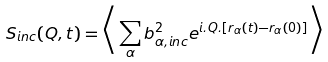Convert formula to latex. <formula><loc_0><loc_0><loc_500><loc_500>S _ { i n c } ( Q , t ) = \Big < \sum _ { \alpha } b _ { \alpha , i n c } ^ { 2 } e ^ { i . Q . [ r _ { \alpha } ( t ) - r _ { \alpha } ( 0 ) ] } \Big > \\</formula> 